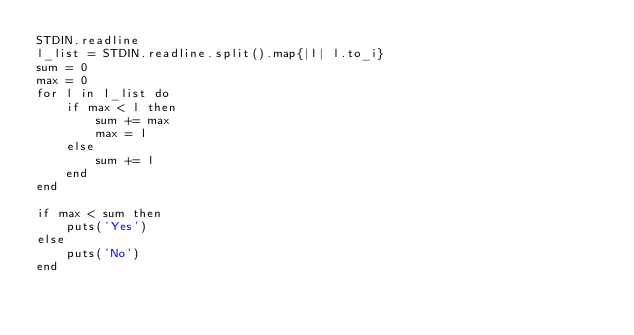<code> <loc_0><loc_0><loc_500><loc_500><_Ruby_>STDIN.readline
l_list = STDIN.readline.split().map{|l| l.to_i}
sum = 0
max = 0
for l in l_list do
    if max < l then
        sum += max
        max = l
    else
        sum += l
    end
end

if max < sum then
    puts('Yes')
else
    puts('No')
end</code> 